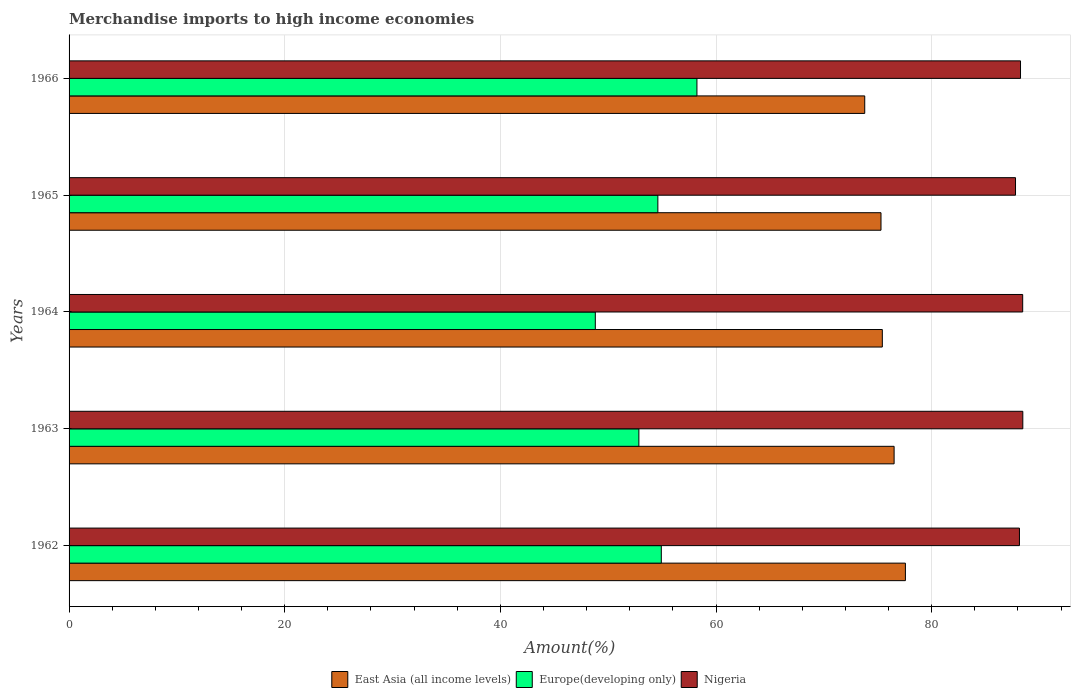Are the number of bars per tick equal to the number of legend labels?
Give a very brief answer. Yes. What is the percentage of amount earned from merchandise imports in East Asia (all income levels) in 1964?
Ensure brevity in your answer.  75.42. Across all years, what is the maximum percentage of amount earned from merchandise imports in Europe(developing only)?
Offer a very short reply. 58.23. Across all years, what is the minimum percentage of amount earned from merchandise imports in Europe(developing only)?
Your response must be concise. 48.8. In which year was the percentage of amount earned from merchandise imports in Europe(developing only) maximum?
Your answer should be compact. 1966. In which year was the percentage of amount earned from merchandise imports in Europe(developing only) minimum?
Your answer should be compact. 1964. What is the total percentage of amount earned from merchandise imports in East Asia (all income levels) in the graph?
Offer a very short reply. 378.59. What is the difference between the percentage of amount earned from merchandise imports in East Asia (all income levels) in 1963 and that in 1966?
Give a very brief answer. 2.72. What is the difference between the percentage of amount earned from merchandise imports in East Asia (all income levels) in 1964 and the percentage of amount earned from merchandise imports in Europe(developing only) in 1963?
Offer a terse response. 22.58. What is the average percentage of amount earned from merchandise imports in Europe(developing only) per year?
Keep it short and to the point. 53.88. In the year 1964, what is the difference between the percentage of amount earned from merchandise imports in Nigeria and percentage of amount earned from merchandise imports in Europe(developing only)?
Provide a short and direct response. 39.64. In how many years, is the percentage of amount earned from merchandise imports in East Asia (all income levels) greater than 40 %?
Make the answer very short. 5. What is the ratio of the percentage of amount earned from merchandise imports in Europe(developing only) in 1963 to that in 1964?
Make the answer very short. 1.08. Is the percentage of amount earned from merchandise imports in East Asia (all income levels) in 1962 less than that in 1964?
Ensure brevity in your answer.  No. What is the difference between the highest and the second highest percentage of amount earned from merchandise imports in Nigeria?
Your answer should be compact. 0.01. What is the difference between the highest and the lowest percentage of amount earned from merchandise imports in Europe(developing only)?
Make the answer very short. 9.43. What does the 2nd bar from the top in 1964 represents?
Ensure brevity in your answer.  Europe(developing only). What does the 3rd bar from the bottom in 1966 represents?
Give a very brief answer. Nigeria. Are all the bars in the graph horizontal?
Offer a very short reply. Yes. How many years are there in the graph?
Your answer should be compact. 5. Are the values on the major ticks of X-axis written in scientific E-notation?
Your answer should be compact. No. How are the legend labels stacked?
Offer a very short reply. Horizontal. What is the title of the graph?
Give a very brief answer. Merchandise imports to high income economies. What is the label or title of the X-axis?
Offer a terse response. Amount(%). What is the Amount(%) of East Asia (all income levels) in 1962?
Keep it short and to the point. 77.56. What is the Amount(%) in Europe(developing only) in 1962?
Your answer should be very brief. 54.93. What is the Amount(%) of Nigeria in 1962?
Provide a short and direct response. 88.14. What is the Amount(%) of East Asia (all income levels) in 1963?
Provide a succinct answer. 76.52. What is the Amount(%) in Europe(developing only) in 1963?
Make the answer very short. 52.84. What is the Amount(%) of Nigeria in 1963?
Your answer should be compact. 88.45. What is the Amount(%) in East Asia (all income levels) in 1964?
Make the answer very short. 75.42. What is the Amount(%) of Europe(developing only) in 1964?
Your response must be concise. 48.8. What is the Amount(%) in Nigeria in 1964?
Provide a short and direct response. 88.44. What is the Amount(%) of East Asia (all income levels) in 1965?
Offer a terse response. 75.3. What is the Amount(%) in Europe(developing only) in 1965?
Make the answer very short. 54.6. What is the Amount(%) of Nigeria in 1965?
Your answer should be very brief. 87.77. What is the Amount(%) of East Asia (all income levels) in 1966?
Your answer should be very brief. 73.79. What is the Amount(%) in Europe(developing only) in 1966?
Offer a very short reply. 58.23. What is the Amount(%) in Nigeria in 1966?
Provide a succinct answer. 88.24. Across all years, what is the maximum Amount(%) in East Asia (all income levels)?
Ensure brevity in your answer.  77.56. Across all years, what is the maximum Amount(%) in Europe(developing only)?
Your answer should be very brief. 58.23. Across all years, what is the maximum Amount(%) of Nigeria?
Provide a succinct answer. 88.45. Across all years, what is the minimum Amount(%) in East Asia (all income levels)?
Ensure brevity in your answer.  73.79. Across all years, what is the minimum Amount(%) in Europe(developing only)?
Your answer should be compact. 48.8. Across all years, what is the minimum Amount(%) in Nigeria?
Your answer should be compact. 87.77. What is the total Amount(%) of East Asia (all income levels) in the graph?
Your answer should be very brief. 378.59. What is the total Amount(%) in Europe(developing only) in the graph?
Provide a succinct answer. 269.41. What is the total Amount(%) of Nigeria in the graph?
Your answer should be very brief. 441.04. What is the difference between the Amount(%) in East Asia (all income levels) in 1962 and that in 1963?
Offer a very short reply. 1.05. What is the difference between the Amount(%) in Europe(developing only) in 1962 and that in 1963?
Keep it short and to the point. 2.08. What is the difference between the Amount(%) of Nigeria in 1962 and that in 1963?
Ensure brevity in your answer.  -0.31. What is the difference between the Amount(%) of East Asia (all income levels) in 1962 and that in 1964?
Provide a succinct answer. 2.14. What is the difference between the Amount(%) of Europe(developing only) in 1962 and that in 1964?
Offer a very short reply. 6.12. What is the difference between the Amount(%) of Nigeria in 1962 and that in 1964?
Offer a very short reply. -0.3. What is the difference between the Amount(%) in East Asia (all income levels) in 1962 and that in 1965?
Your answer should be compact. 2.26. What is the difference between the Amount(%) of Europe(developing only) in 1962 and that in 1965?
Provide a succinct answer. 0.32. What is the difference between the Amount(%) in Nigeria in 1962 and that in 1965?
Your answer should be compact. 0.36. What is the difference between the Amount(%) of East Asia (all income levels) in 1962 and that in 1966?
Your response must be concise. 3.77. What is the difference between the Amount(%) in Europe(developing only) in 1962 and that in 1966?
Your answer should be compact. -3.3. What is the difference between the Amount(%) of Nigeria in 1962 and that in 1966?
Provide a short and direct response. -0.1. What is the difference between the Amount(%) of East Asia (all income levels) in 1963 and that in 1964?
Give a very brief answer. 1.09. What is the difference between the Amount(%) of Europe(developing only) in 1963 and that in 1964?
Your response must be concise. 4.04. What is the difference between the Amount(%) of Nigeria in 1963 and that in 1964?
Offer a very short reply. 0.01. What is the difference between the Amount(%) in East Asia (all income levels) in 1963 and that in 1965?
Make the answer very short. 1.22. What is the difference between the Amount(%) in Europe(developing only) in 1963 and that in 1965?
Provide a succinct answer. -1.76. What is the difference between the Amount(%) of Nigeria in 1963 and that in 1965?
Your response must be concise. 0.68. What is the difference between the Amount(%) of East Asia (all income levels) in 1963 and that in 1966?
Your response must be concise. 2.72. What is the difference between the Amount(%) in Europe(developing only) in 1963 and that in 1966?
Ensure brevity in your answer.  -5.39. What is the difference between the Amount(%) in Nigeria in 1963 and that in 1966?
Keep it short and to the point. 0.21. What is the difference between the Amount(%) in East Asia (all income levels) in 1964 and that in 1965?
Give a very brief answer. 0.12. What is the difference between the Amount(%) in Europe(developing only) in 1964 and that in 1965?
Your answer should be very brief. -5.8. What is the difference between the Amount(%) of Nigeria in 1964 and that in 1965?
Provide a succinct answer. 0.66. What is the difference between the Amount(%) in East Asia (all income levels) in 1964 and that in 1966?
Your response must be concise. 1.63. What is the difference between the Amount(%) of Europe(developing only) in 1964 and that in 1966?
Offer a terse response. -9.43. What is the difference between the Amount(%) of Nigeria in 1964 and that in 1966?
Provide a succinct answer. 0.2. What is the difference between the Amount(%) in East Asia (all income levels) in 1965 and that in 1966?
Offer a very short reply. 1.51. What is the difference between the Amount(%) in Europe(developing only) in 1965 and that in 1966?
Your answer should be compact. -3.62. What is the difference between the Amount(%) of Nigeria in 1965 and that in 1966?
Your response must be concise. -0.46. What is the difference between the Amount(%) of East Asia (all income levels) in 1962 and the Amount(%) of Europe(developing only) in 1963?
Make the answer very short. 24.72. What is the difference between the Amount(%) in East Asia (all income levels) in 1962 and the Amount(%) in Nigeria in 1963?
Offer a terse response. -10.89. What is the difference between the Amount(%) of Europe(developing only) in 1962 and the Amount(%) of Nigeria in 1963?
Keep it short and to the point. -33.52. What is the difference between the Amount(%) of East Asia (all income levels) in 1962 and the Amount(%) of Europe(developing only) in 1964?
Offer a very short reply. 28.76. What is the difference between the Amount(%) in East Asia (all income levels) in 1962 and the Amount(%) in Nigeria in 1964?
Provide a succinct answer. -10.88. What is the difference between the Amount(%) of Europe(developing only) in 1962 and the Amount(%) of Nigeria in 1964?
Make the answer very short. -33.51. What is the difference between the Amount(%) in East Asia (all income levels) in 1962 and the Amount(%) in Europe(developing only) in 1965?
Give a very brief answer. 22.96. What is the difference between the Amount(%) of East Asia (all income levels) in 1962 and the Amount(%) of Nigeria in 1965?
Your answer should be very brief. -10.21. What is the difference between the Amount(%) in Europe(developing only) in 1962 and the Amount(%) in Nigeria in 1965?
Keep it short and to the point. -32.85. What is the difference between the Amount(%) of East Asia (all income levels) in 1962 and the Amount(%) of Europe(developing only) in 1966?
Your answer should be compact. 19.33. What is the difference between the Amount(%) of East Asia (all income levels) in 1962 and the Amount(%) of Nigeria in 1966?
Keep it short and to the point. -10.68. What is the difference between the Amount(%) in Europe(developing only) in 1962 and the Amount(%) in Nigeria in 1966?
Ensure brevity in your answer.  -33.31. What is the difference between the Amount(%) in East Asia (all income levels) in 1963 and the Amount(%) in Europe(developing only) in 1964?
Give a very brief answer. 27.71. What is the difference between the Amount(%) of East Asia (all income levels) in 1963 and the Amount(%) of Nigeria in 1964?
Your response must be concise. -11.92. What is the difference between the Amount(%) of Europe(developing only) in 1963 and the Amount(%) of Nigeria in 1964?
Offer a very short reply. -35.6. What is the difference between the Amount(%) in East Asia (all income levels) in 1963 and the Amount(%) in Europe(developing only) in 1965?
Offer a very short reply. 21.91. What is the difference between the Amount(%) in East Asia (all income levels) in 1963 and the Amount(%) in Nigeria in 1965?
Provide a succinct answer. -11.26. What is the difference between the Amount(%) in Europe(developing only) in 1963 and the Amount(%) in Nigeria in 1965?
Provide a short and direct response. -34.93. What is the difference between the Amount(%) in East Asia (all income levels) in 1963 and the Amount(%) in Europe(developing only) in 1966?
Your answer should be very brief. 18.29. What is the difference between the Amount(%) of East Asia (all income levels) in 1963 and the Amount(%) of Nigeria in 1966?
Provide a succinct answer. -11.72. What is the difference between the Amount(%) of Europe(developing only) in 1963 and the Amount(%) of Nigeria in 1966?
Make the answer very short. -35.39. What is the difference between the Amount(%) in East Asia (all income levels) in 1964 and the Amount(%) in Europe(developing only) in 1965?
Your answer should be very brief. 20.82. What is the difference between the Amount(%) in East Asia (all income levels) in 1964 and the Amount(%) in Nigeria in 1965?
Offer a terse response. -12.35. What is the difference between the Amount(%) in Europe(developing only) in 1964 and the Amount(%) in Nigeria in 1965?
Give a very brief answer. -38.97. What is the difference between the Amount(%) in East Asia (all income levels) in 1964 and the Amount(%) in Europe(developing only) in 1966?
Ensure brevity in your answer.  17.19. What is the difference between the Amount(%) in East Asia (all income levels) in 1964 and the Amount(%) in Nigeria in 1966?
Ensure brevity in your answer.  -12.82. What is the difference between the Amount(%) of Europe(developing only) in 1964 and the Amount(%) of Nigeria in 1966?
Provide a short and direct response. -39.44. What is the difference between the Amount(%) in East Asia (all income levels) in 1965 and the Amount(%) in Europe(developing only) in 1966?
Keep it short and to the point. 17.07. What is the difference between the Amount(%) in East Asia (all income levels) in 1965 and the Amount(%) in Nigeria in 1966?
Ensure brevity in your answer.  -12.94. What is the difference between the Amount(%) of Europe(developing only) in 1965 and the Amount(%) of Nigeria in 1966?
Provide a succinct answer. -33.63. What is the average Amount(%) of East Asia (all income levels) per year?
Ensure brevity in your answer.  75.72. What is the average Amount(%) in Europe(developing only) per year?
Your response must be concise. 53.88. What is the average Amount(%) of Nigeria per year?
Provide a succinct answer. 88.21. In the year 1962, what is the difference between the Amount(%) of East Asia (all income levels) and Amount(%) of Europe(developing only)?
Make the answer very short. 22.64. In the year 1962, what is the difference between the Amount(%) of East Asia (all income levels) and Amount(%) of Nigeria?
Your answer should be very brief. -10.58. In the year 1962, what is the difference between the Amount(%) of Europe(developing only) and Amount(%) of Nigeria?
Make the answer very short. -33.21. In the year 1963, what is the difference between the Amount(%) in East Asia (all income levels) and Amount(%) in Europe(developing only)?
Ensure brevity in your answer.  23.67. In the year 1963, what is the difference between the Amount(%) of East Asia (all income levels) and Amount(%) of Nigeria?
Your response must be concise. -11.94. In the year 1963, what is the difference between the Amount(%) of Europe(developing only) and Amount(%) of Nigeria?
Ensure brevity in your answer.  -35.61. In the year 1964, what is the difference between the Amount(%) of East Asia (all income levels) and Amount(%) of Europe(developing only)?
Provide a succinct answer. 26.62. In the year 1964, what is the difference between the Amount(%) in East Asia (all income levels) and Amount(%) in Nigeria?
Your answer should be compact. -13.02. In the year 1964, what is the difference between the Amount(%) of Europe(developing only) and Amount(%) of Nigeria?
Your answer should be very brief. -39.64. In the year 1965, what is the difference between the Amount(%) in East Asia (all income levels) and Amount(%) in Europe(developing only)?
Your response must be concise. 20.69. In the year 1965, what is the difference between the Amount(%) in East Asia (all income levels) and Amount(%) in Nigeria?
Offer a very short reply. -12.47. In the year 1965, what is the difference between the Amount(%) in Europe(developing only) and Amount(%) in Nigeria?
Ensure brevity in your answer.  -33.17. In the year 1966, what is the difference between the Amount(%) in East Asia (all income levels) and Amount(%) in Europe(developing only)?
Offer a terse response. 15.56. In the year 1966, what is the difference between the Amount(%) in East Asia (all income levels) and Amount(%) in Nigeria?
Your answer should be very brief. -14.45. In the year 1966, what is the difference between the Amount(%) of Europe(developing only) and Amount(%) of Nigeria?
Provide a short and direct response. -30.01. What is the ratio of the Amount(%) of East Asia (all income levels) in 1962 to that in 1963?
Provide a short and direct response. 1.01. What is the ratio of the Amount(%) in Europe(developing only) in 1962 to that in 1963?
Offer a very short reply. 1.04. What is the ratio of the Amount(%) in Nigeria in 1962 to that in 1963?
Provide a succinct answer. 1. What is the ratio of the Amount(%) of East Asia (all income levels) in 1962 to that in 1964?
Keep it short and to the point. 1.03. What is the ratio of the Amount(%) in Europe(developing only) in 1962 to that in 1964?
Keep it short and to the point. 1.13. What is the ratio of the Amount(%) in East Asia (all income levels) in 1962 to that in 1965?
Ensure brevity in your answer.  1.03. What is the ratio of the Amount(%) in Europe(developing only) in 1962 to that in 1965?
Your answer should be very brief. 1.01. What is the ratio of the Amount(%) in Nigeria in 1962 to that in 1965?
Your answer should be very brief. 1. What is the ratio of the Amount(%) in East Asia (all income levels) in 1962 to that in 1966?
Keep it short and to the point. 1.05. What is the ratio of the Amount(%) in Europe(developing only) in 1962 to that in 1966?
Keep it short and to the point. 0.94. What is the ratio of the Amount(%) in East Asia (all income levels) in 1963 to that in 1964?
Make the answer very short. 1.01. What is the ratio of the Amount(%) in Europe(developing only) in 1963 to that in 1964?
Your answer should be very brief. 1.08. What is the ratio of the Amount(%) of East Asia (all income levels) in 1963 to that in 1965?
Provide a short and direct response. 1.02. What is the ratio of the Amount(%) in Europe(developing only) in 1963 to that in 1965?
Your answer should be very brief. 0.97. What is the ratio of the Amount(%) of Nigeria in 1963 to that in 1965?
Your answer should be very brief. 1.01. What is the ratio of the Amount(%) in East Asia (all income levels) in 1963 to that in 1966?
Offer a very short reply. 1.04. What is the ratio of the Amount(%) of Europe(developing only) in 1963 to that in 1966?
Give a very brief answer. 0.91. What is the ratio of the Amount(%) in Nigeria in 1963 to that in 1966?
Make the answer very short. 1. What is the ratio of the Amount(%) in Europe(developing only) in 1964 to that in 1965?
Make the answer very short. 0.89. What is the ratio of the Amount(%) in Nigeria in 1964 to that in 1965?
Provide a short and direct response. 1.01. What is the ratio of the Amount(%) of East Asia (all income levels) in 1964 to that in 1966?
Keep it short and to the point. 1.02. What is the ratio of the Amount(%) of Europe(developing only) in 1964 to that in 1966?
Your answer should be compact. 0.84. What is the ratio of the Amount(%) in Nigeria in 1964 to that in 1966?
Give a very brief answer. 1. What is the ratio of the Amount(%) of East Asia (all income levels) in 1965 to that in 1966?
Your answer should be very brief. 1.02. What is the ratio of the Amount(%) in Europe(developing only) in 1965 to that in 1966?
Provide a short and direct response. 0.94. What is the difference between the highest and the second highest Amount(%) in East Asia (all income levels)?
Give a very brief answer. 1.05. What is the difference between the highest and the second highest Amount(%) in Europe(developing only)?
Offer a very short reply. 3.3. What is the difference between the highest and the second highest Amount(%) in Nigeria?
Ensure brevity in your answer.  0.01. What is the difference between the highest and the lowest Amount(%) of East Asia (all income levels)?
Your response must be concise. 3.77. What is the difference between the highest and the lowest Amount(%) of Europe(developing only)?
Your answer should be very brief. 9.43. What is the difference between the highest and the lowest Amount(%) of Nigeria?
Make the answer very short. 0.68. 